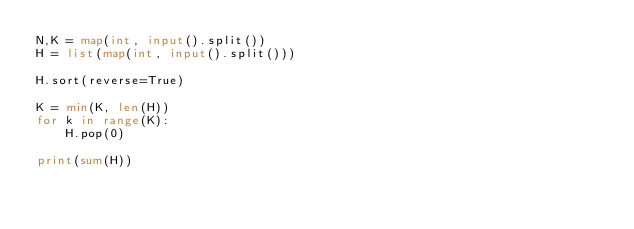<code> <loc_0><loc_0><loc_500><loc_500><_Python_>N,K = map(int, input().split())
H = list(map(int, input().split()))
 
H.sort(reverse=True)
 
K = min(K, len(H))
for k in range(K):
    H.pop(0)
 
print(sum(H))</code> 